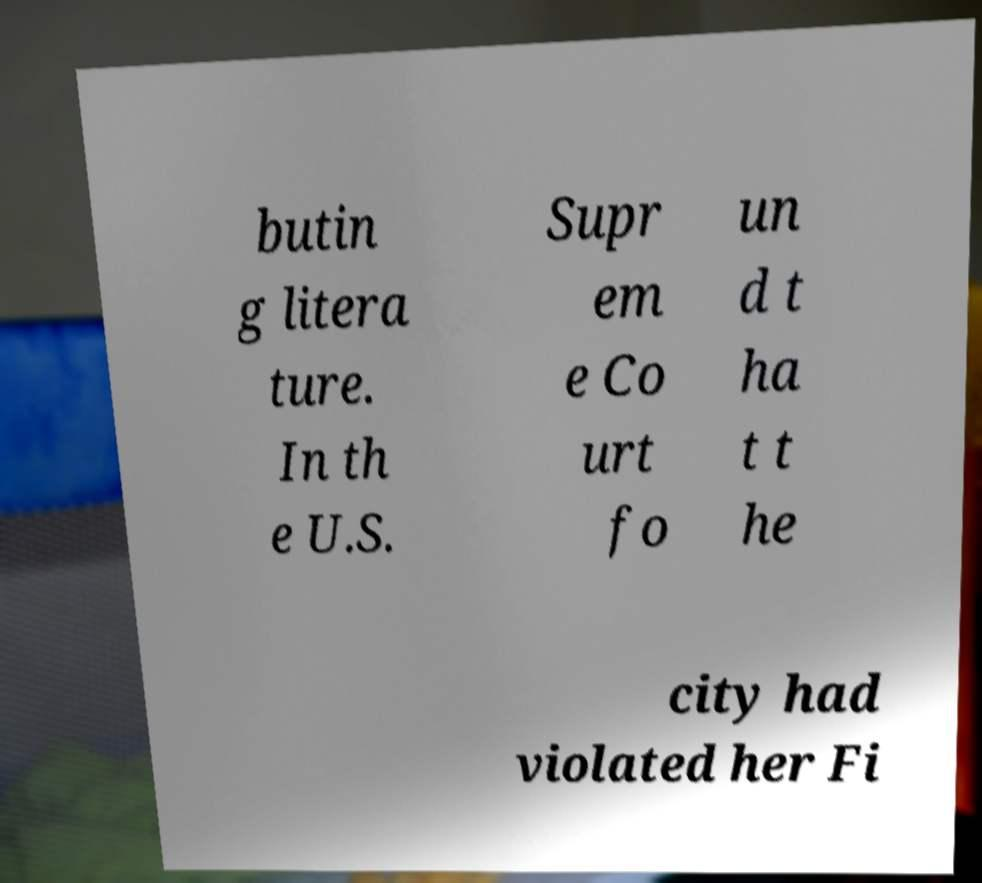There's text embedded in this image that I need extracted. Can you transcribe it verbatim? butin g litera ture. In th e U.S. Supr em e Co urt fo un d t ha t t he city had violated her Fi 